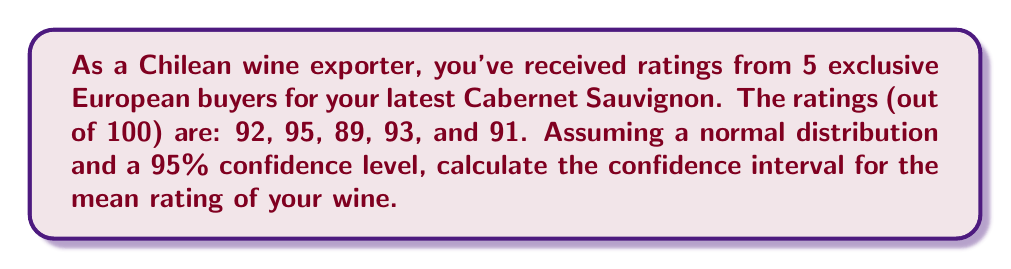What is the answer to this math problem? To calculate the confidence interval, we'll follow these steps:

1. Calculate the sample mean ($\bar{x}$):
   $$\bar{x} = \frac{92 + 95 + 89 + 93 + 91}{5} = 92$$

2. Calculate the sample standard deviation ($s$):
   $$s = \sqrt{\frac{\sum(x_i - \bar{x})^2}{n - 1}}$$
   $$s = \sqrt{\frac{(92-92)^2 + (95-92)^2 + (89-92)^2 + (93-92)^2 + (91-92)^2}{5 - 1}} = 2.24$$

3. Determine the t-value for 95% confidence level and 4 degrees of freedom:
   $t_{0.025, 4} = 2.776$ (from t-distribution table)

4. Calculate the margin of error:
   $$\text{Margin of Error} = t_{0.025, 4} \cdot \frac{s}{\sqrt{n}} = 2.776 \cdot \frac{2.24}{\sqrt{5}} = 2.78$$

5. Compute the confidence interval:
   $$\text{CI} = \bar{x} \pm \text{Margin of Error}$$
   $$\text{CI} = 92 \pm 2.78$$
   $$\text{CI} = (89.22, 94.78)$$
Answer: (89.22, 94.78) 